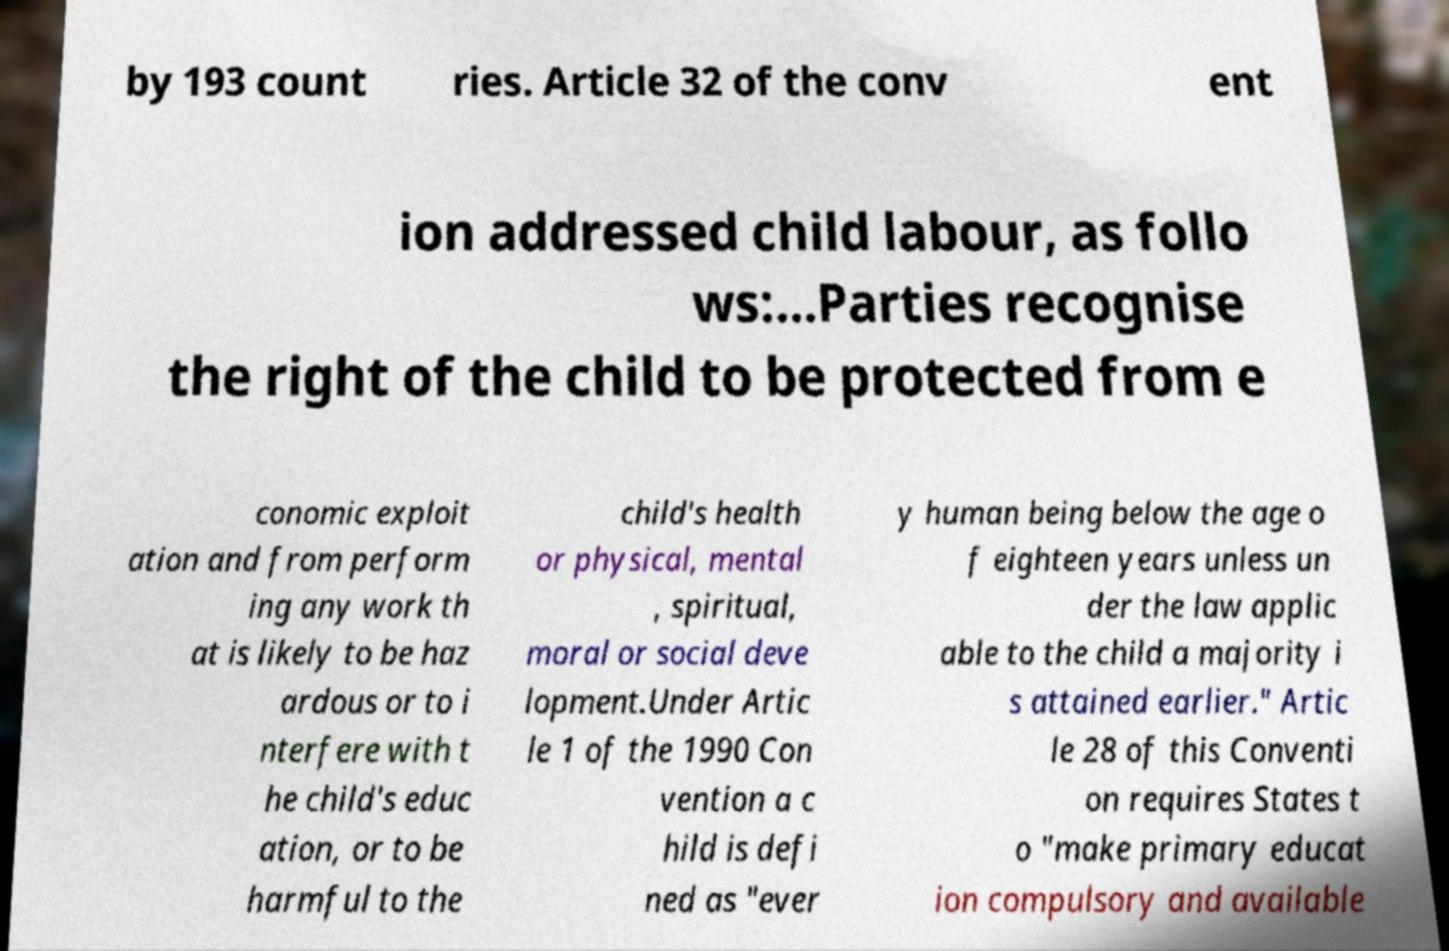Please read and relay the text visible in this image. What does it say? by 193 count ries. Article 32 of the conv ent ion addressed child labour, as follo ws:...Parties recognise the right of the child to be protected from e conomic exploit ation and from perform ing any work th at is likely to be haz ardous or to i nterfere with t he child's educ ation, or to be harmful to the child's health or physical, mental , spiritual, moral or social deve lopment.Under Artic le 1 of the 1990 Con vention a c hild is defi ned as "ever y human being below the age o f eighteen years unless un der the law applic able to the child a majority i s attained earlier." Artic le 28 of this Conventi on requires States t o "make primary educat ion compulsory and available 